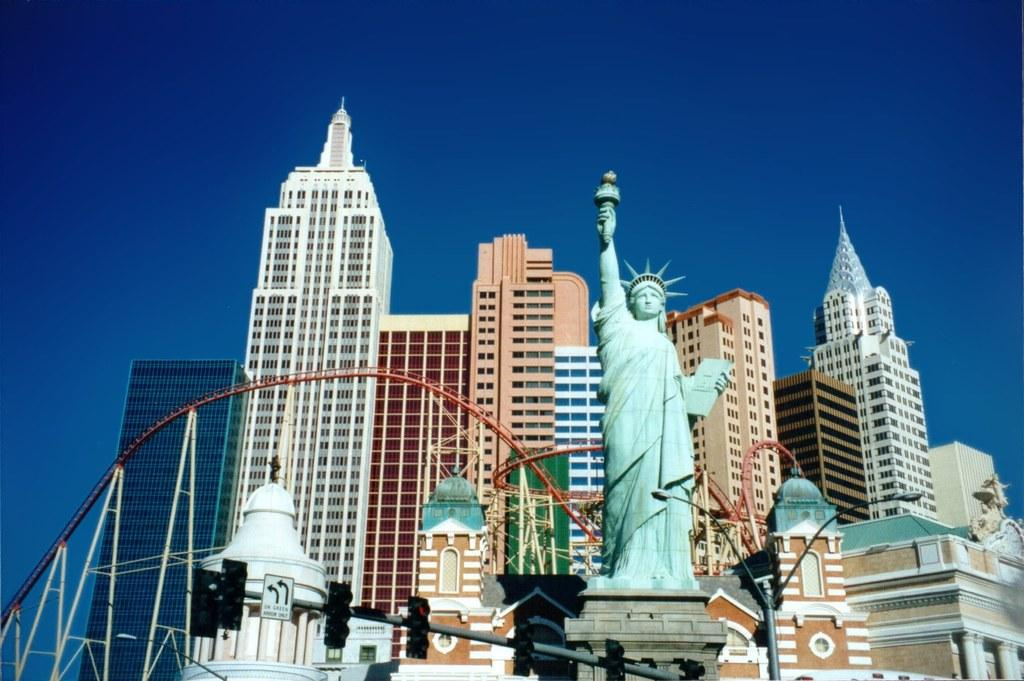What is the main subject in the center of the image? There is a statue of liberty in the center of the image. What can be seen at the bottom of the image? There are traffic lights and poles at the bottom of the image. What is visible in the background of the image? There are buildings and the sky in the background of the image. What type of food is being rewarded to the statue of liberty in the image? There is no food or reward present in the image; it only features the statue of liberty, traffic lights, poles, buildings, and the sky. 